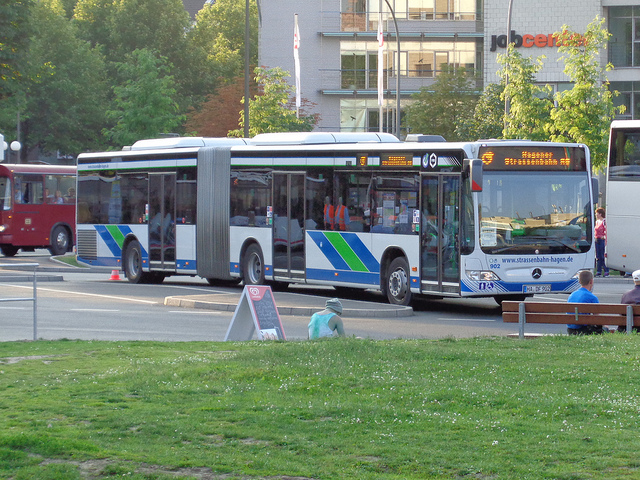Read all the text in this image. job 